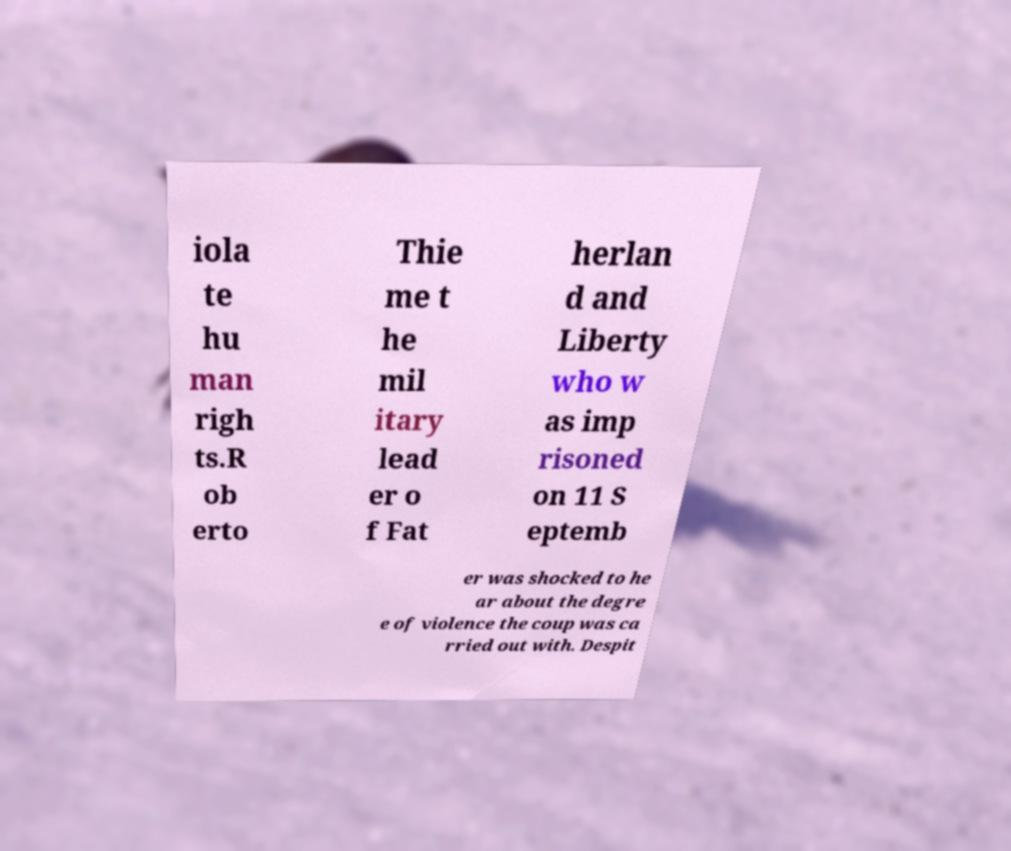Please identify and transcribe the text found in this image. iola te hu man righ ts.R ob erto Thie me t he mil itary lead er o f Fat herlan d and Liberty who w as imp risoned on 11 S eptemb er was shocked to he ar about the degre e of violence the coup was ca rried out with. Despit 